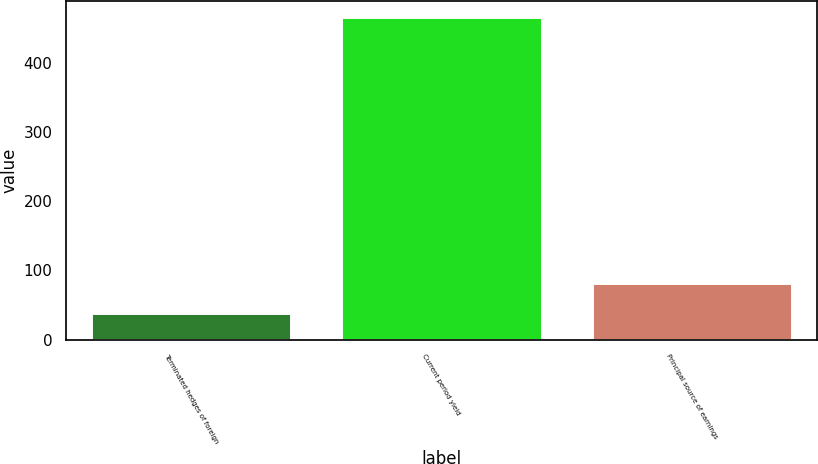Convert chart. <chart><loc_0><loc_0><loc_500><loc_500><bar_chart><fcel>Terminated hedges of foreign<fcel>Current period yield<fcel>Principal source of earnings<nl><fcel>39<fcel>466<fcel>81.7<nl></chart> 